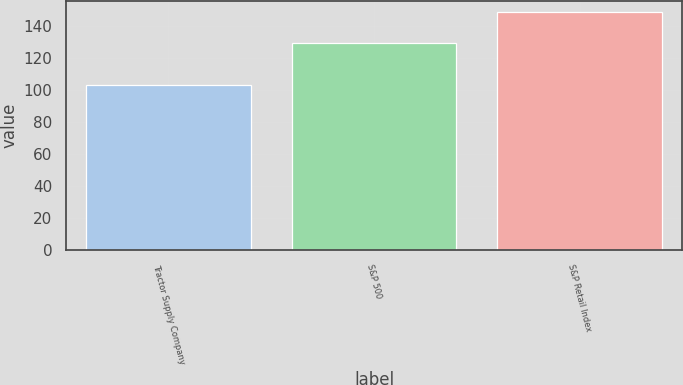Convert chart. <chart><loc_0><loc_0><loc_500><loc_500><bar_chart><fcel>Tractor Supply Company<fcel>S&P 500<fcel>S&P Retail Index<nl><fcel>103.33<fcel>129.55<fcel>148.53<nl></chart> 